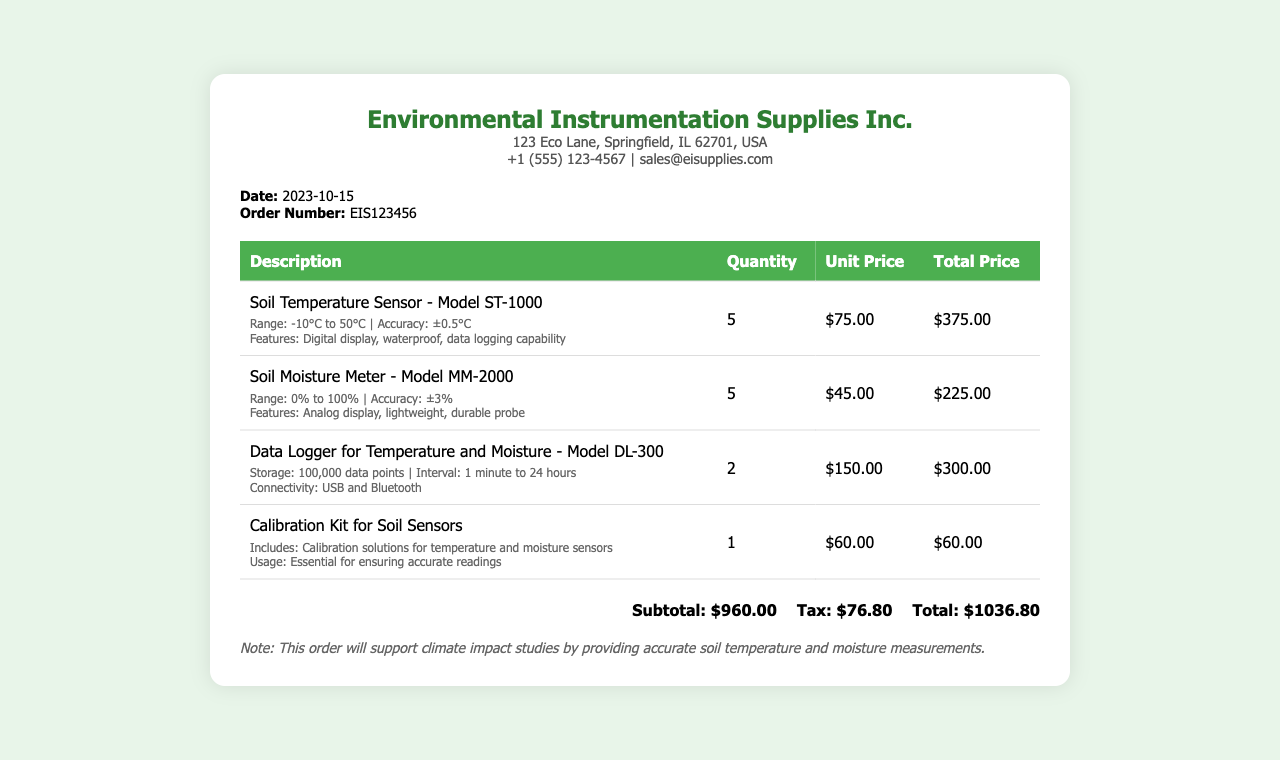What is the date of the order? The date of the order is specified in the document, which is 2023-10-15.
Answer: 2023-10-15 What is the order number? The order number is provided in the document, which is EIS123456.
Answer: EIS123456 How many Soil Temperature Sensors were ordered? The quantity of Soil Temperature Sensors is listed in the document as 5.
Answer: 5 What is the total amount due? The total amount due is given at the end of the document, which is $1036.80.
Answer: $1036.80 What is the range of the Soil Moisture Meter? The range for the Soil Moisture Meter is mentioned in the specifications, which is 0% to 100%.
Answer: 0% to 100% How many types of sensors are listed in the receipt? The document lists four different types of items, which are sensors and a calibration kit.
Answer: 4 What type of data logger is included in the order? The data logger specified in the receipt is Model DL-300.
Answer: Model DL-300 What is included in the Calibration Kit for Soil Sensors? The Calibration Kit includes calibration solutions for both temperature and moisture sensors.
Answer: Calibration solutions for temperature and moisture sensors What is the tax amount on the order? The tax amount is specified in the total section of the document as $76.80.
Answer: $76.80 